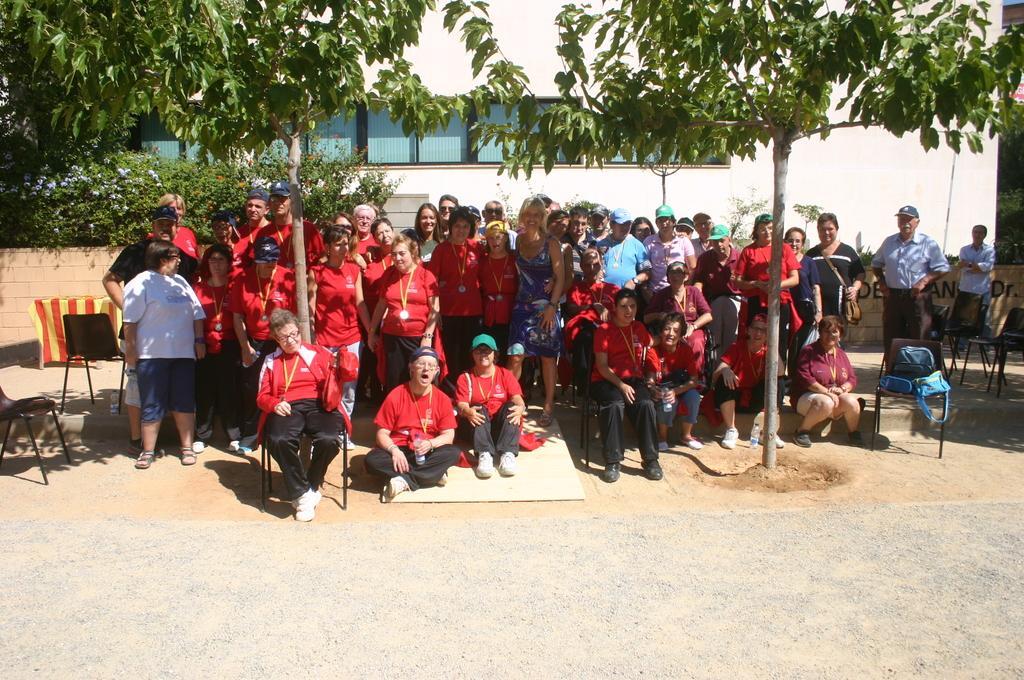Describe this image in one or two sentences. In this picture I can see group of people posing for a picture. There are also bags,chairs ,trees and a building. 